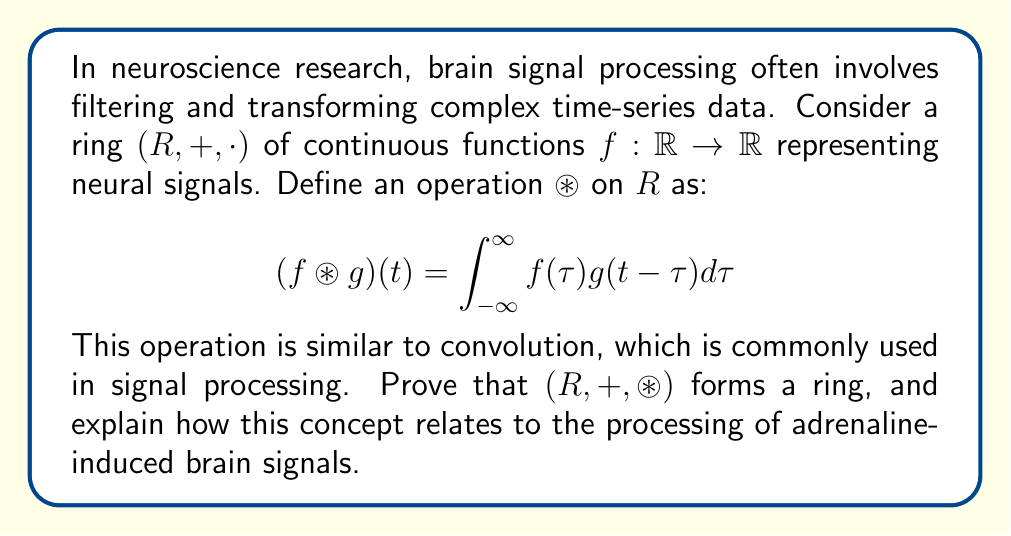Teach me how to tackle this problem. To prove that $(R, +, \circledast)$ forms a ring, we need to show that it satisfies the ring axioms:

1. $(R, +)$ is an abelian group:
   - Closure and associativity for addition are inherited from the original ring structure.
   - The zero function $f(t) = 0$ serves as the additive identity.
   - For each $f \in R$, its additive inverse is $-f$.

2. $(R, \circledast)$ is a monoid:
   - Closure: For any $f, g \in R$, $f \circledast g$ is a continuous function, thus in $R$.
   - Associativity: $(f \circledast g) \circledast h = f \circledast (g \circledast h)$ (can be proved using Fubini's theorem).
   - Identity: The Dirac delta function $\delta(t)$ serves as the identity for $\circledast$.

3. Distributivity:
   - Left distributivity: $f \circledast (g + h) = f \circledast g + f \circledast h$
   - Right distributivity: $(f + g) \circledast h = f \circledast h + g \circledast h$

These properties can be verified using the definition of $\circledast$ and properties of integrals.

Relation to adrenaline-induced brain signals:
In studying the impact of adrenaline on the brain, researchers often need to process and analyze complex neural signals. The ring structure $(R, +, \circledast)$ provides a mathematical framework for these operations:

1. Addition (+) represents the superposition of different neural signals, which is crucial when studying how adrenaline affects multiple brain regions simultaneously.

2. The $\circledast$ operation models the filtering and convolution of signals, which is essential for:
   a) Removing noise from raw neural data.
   b) Applying various filters to isolate specific frequency bands associated with adrenaline-induced activity.
   c) Modeling the spread and influence of adrenaline-related signals across different brain areas.

3. The ring structure ensures that these operations can be combined and applied consistently, allowing for complex signal processing pipelines in adrenaline-related neuroscience research.
Answer: $(R, +, \circledast)$ forms a ring, providing a mathematical framework for processing adrenaline-induced brain signals through superposition and convolution operations. 